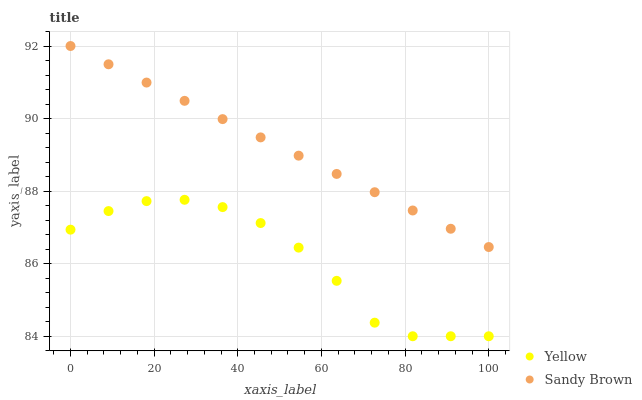Does Yellow have the minimum area under the curve?
Answer yes or no. Yes. Does Sandy Brown have the maximum area under the curve?
Answer yes or no. Yes. Does Yellow have the maximum area under the curve?
Answer yes or no. No. Is Sandy Brown the smoothest?
Answer yes or no. Yes. Is Yellow the roughest?
Answer yes or no. Yes. Is Yellow the smoothest?
Answer yes or no. No. Does Yellow have the lowest value?
Answer yes or no. Yes. Does Sandy Brown have the highest value?
Answer yes or no. Yes. Does Yellow have the highest value?
Answer yes or no. No. Is Yellow less than Sandy Brown?
Answer yes or no. Yes. Is Sandy Brown greater than Yellow?
Answer yes or no. Yes. Does Yellow intersect Sandy Brown?
Answer yes or no. No. 